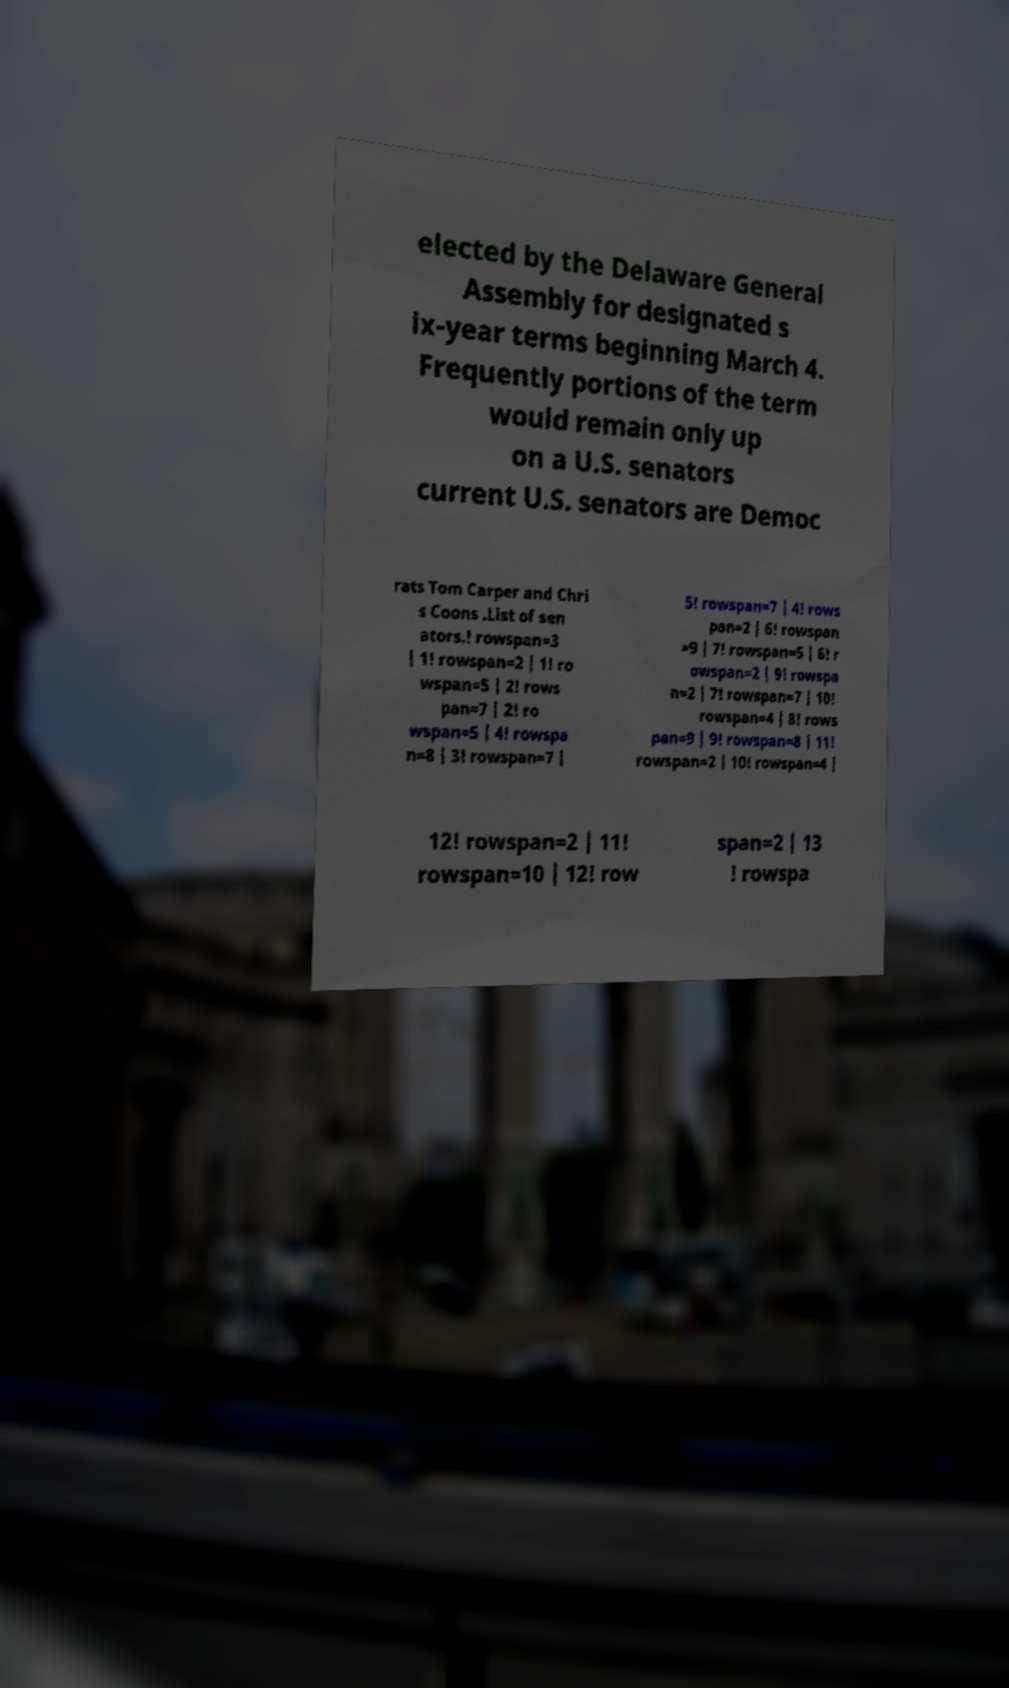Please read and relay the text visible in this image. What does it say? elected by the Delaware General Assembly for designated s ix-year terms beginning March 4. Frequently portions of the term would remain only up on a U.S. senators current U.S. senators are Democ rats Tom Carper and Chri s Coons .List of sen ators.! rowspan=3 | 1! rowspan=2 | 1! ro wspan=5 | 2! rows pan=7 | 2! ro wspan=5 | 4! rowspa n=8 | 3! rowspan=7 | 5! rowspan=7 | 4! rows pan=2 | 6! rowspan =9 | 7! rowspan=5 | 6! r owspan=2 | 9! rowspa n=2 | 7! rowspan=7 | 10! rowspan=4 | 8! rows pan=9 | 9! rowspan=8 | 11! rowspan=2 | 10! rowspan=4 | 12! rowspan=2 | 11! rowspan=10 | 12! row span=2 | 13 ! rowspa 